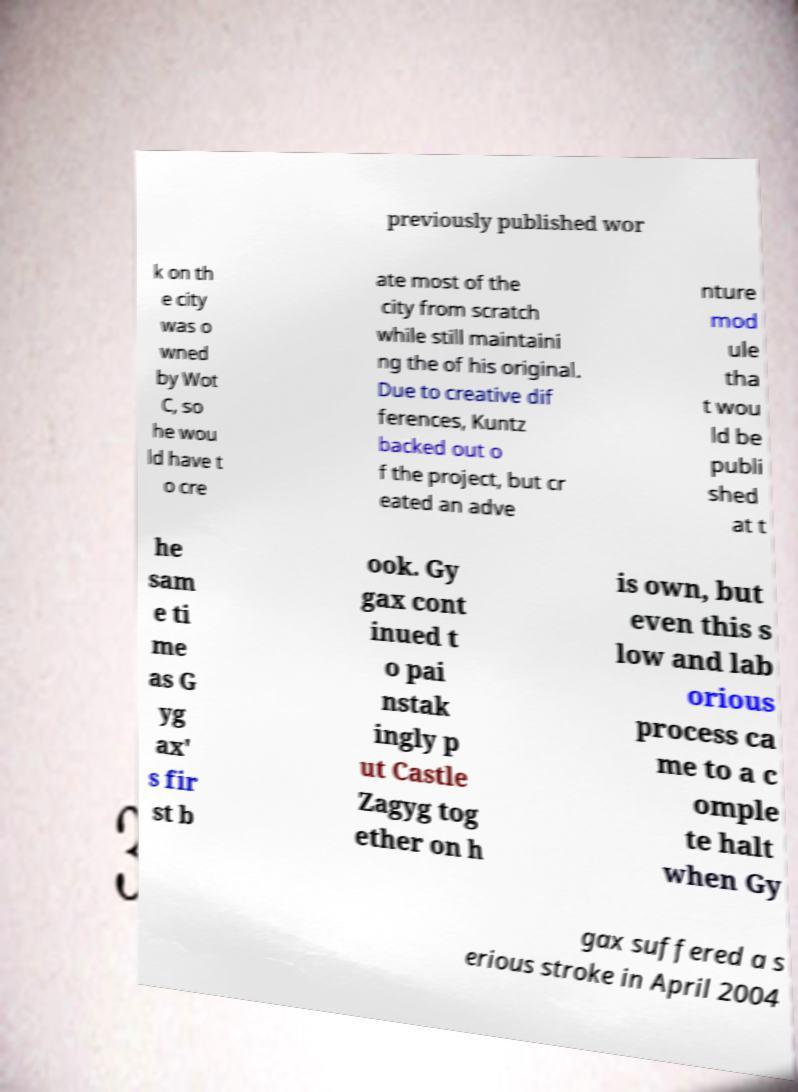Could you extract and type out the text from this image? previously published wor k on th e city was o wned by Wot C, so he wou ld have t o cre ate most of the city from scratch while still maintaini ng the of his original. Due to creative dif ferences, Kuntz backed out o f the project, but cr eated an adve nture mod ule tha t wou ld be publi shed at t he sam e ti me as G yg ax' s fir st b ook. Gy gax cont inued t o pai nstak ingly p ut Castle Zagyg tog ether on h is own, but even this s low and lab orious process ca me to a c omple te halt when Gy gax suffered a s erious stroke in April 2004 